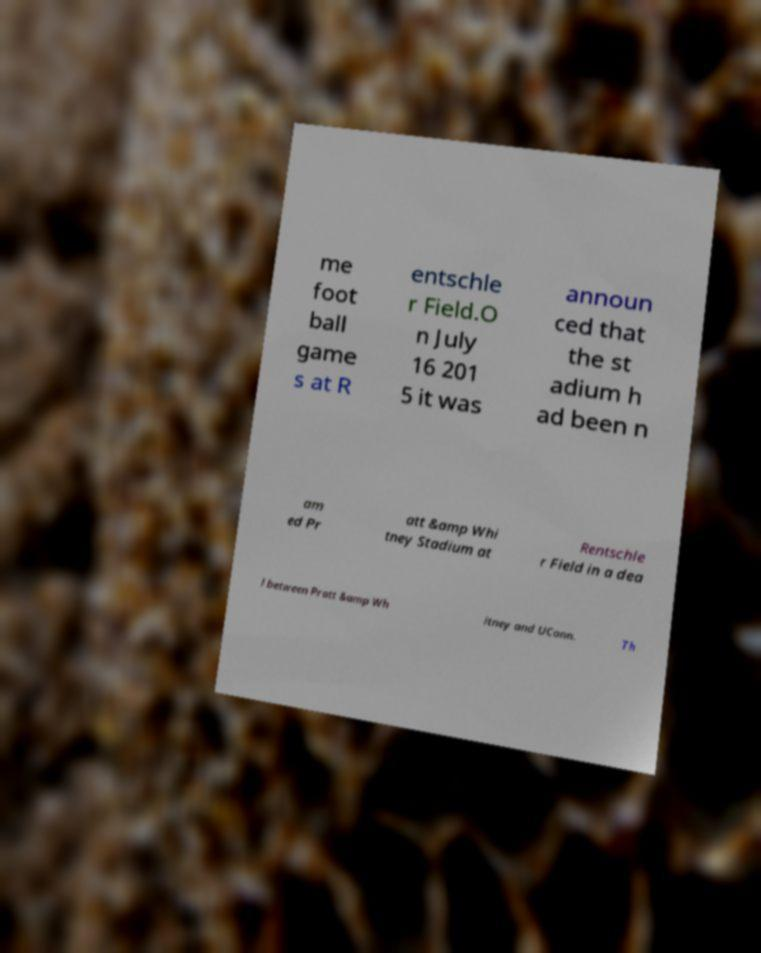What messages or text are displayed in this image? I need them in a readable, typed format. me foot ball game s at R entschle r Field.O n July 16 201 5 it was announ ced that the st adium h ad been n am ed Pr att &amp Whi tney Stadium at Rentschle r Field in a dea l between Pratt &amp Wh itney and UConn. Th 